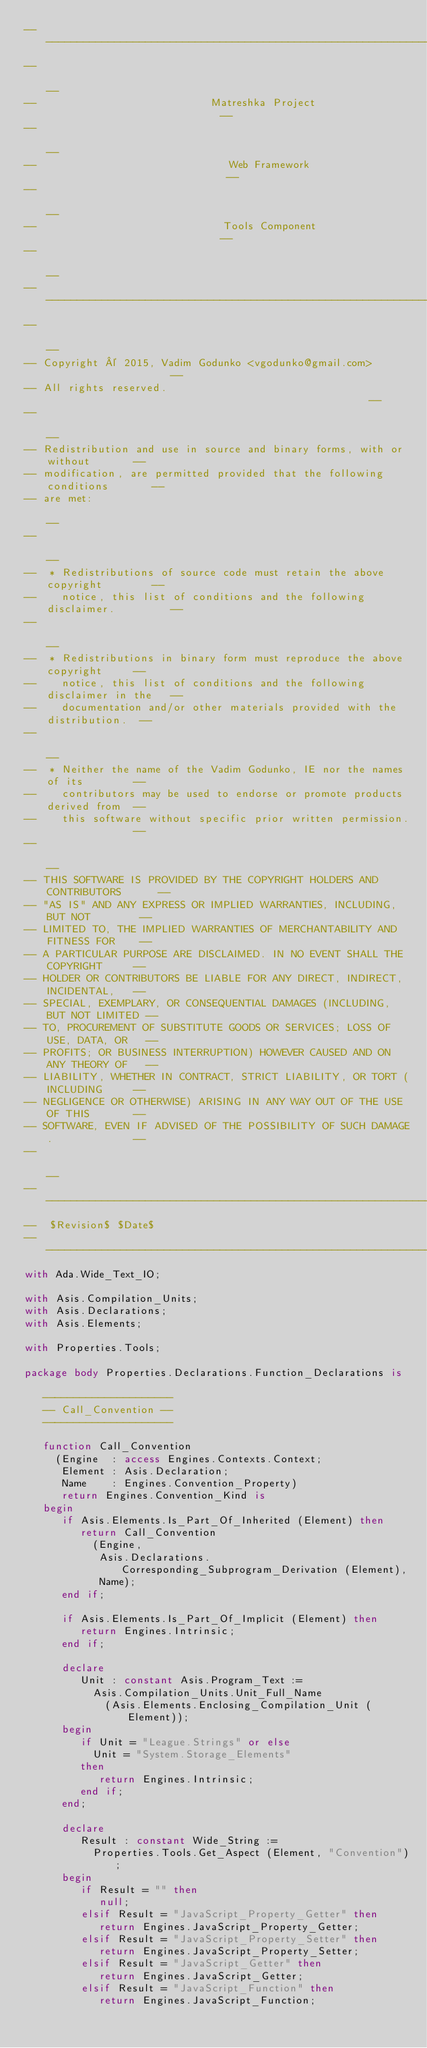<code> <loc_0><loc_0><loc_500><loc_500><_Ada_>------------------------------------------------------------------------------
--                                                                          --
--                            Matreshka Project                             --
--                                                                          --
--                               Web Framework                              --
--                                                                          --
--                              Tools Component                             --
--                                                                          --
------------------------------------------------------------------------------
--                                                                          --
-- Copyright © 2015, Vadim Godunko <vgodunko@gmail.com>                     --
-- All rights reserved.                                                     --
--                                                                          --
-- Redistribution and use in source and binary forms, with or without       --
-- modification, are permitted provided that the following conditions       --
-- are met:                                                                 --
--                                                                          --
--  * Redistributions of source code must retain the above copyright        --
--    notice, this list of conditions and the following disclaimer.         --
--                                                                          --
--  * Redistributions in binary form must reproduce the above copyright     --
--    notice, this list of conditions and the following disclaimer in the   --
--    documentation and/or other materials provided with the distribution.  --
--                                                                          --
--  * Neither the name of the Vadim Godunko, IE nor the names of its        --
--    contributors may be used to endorse or promote products derived from  --
--    this software without specific prior written permission.              --
--                                                                          --
-- THIS SOFTWARE IS PROVIDED BY THE COPYRIGHT HOLDERS AND CONTRIBUTORS      --
-- "AS IS" AND ANY EXPRESS OR IMPLIED WARRANTIES, INCLUDING, BUT NOT        --
-- LIMITED TO, THE IMPLIED WARRANTIES OF MERCHANTABILITY AND FITNESS FOR    --
-- A PARTICULAR PURPOSE ARE DISCLAIMED. IN NO EVENT SHALL THE COPYRIGHT     --
-- HOLDER OR CONTRIBUTORS BE LIABLE FOR ANY DIRECT, INDIRECT, INCIDENTAL,   --
-- SPECIAL, EXEMPLARY, OR CONSEQUENTIAL DAMAGES (INCLUDING, BUT NOT LIMITED --
-- TO, PROCUREMENT OF SUBSTITUTE GOODS OR SERVICES; LOSS OF USE, DATA, OR   --
-- PROFITS; OR BUSINESS INTERRUPTION) HOWEVER CAUSED AND ON ANY THEORY OF   --
-- LIABILITY, WHETHER IN CONTRACT, STRICT LIABILITY, OR TORT (INCLUDING     --
-- NEGLIGENCE OR OTHERWISE) ARISING IN ANY WAY OUT OF THE USE OF THIS       --
-- SOFTWARE, EVEN IF ADVISED OF THE POSSIBILITY OF SUCH DAMAGE.             --
--                                                                          --
------------------------------------------------------------------------------
--  $Revision$ $Date$
------------------------------------------------------------------------------
with Ada.Wide_Text_IO;

with Asis.Compilation_Units;
with Asis.Declarations;
with Asis.Elements;

with Properties.Tools;

package body Properties.Declarations.Function_Declarations is

   ---------------------
   -- Call_Convention --
   ---------------------

   function Call_Convention
     (Engine  : access Engines.Contexts.Context;
      Element : Asis.Declaration;
      Name    : Engines.Convention_Property)
      return Engines.Convention_Kind is
   begin
      if Asis.Elements.Is_Part_Of_Inherited (Element) then
         return Call_Convention
           (Engine,
            Asis.Declarations.Corresponding_Subprogram_Derivation (Element),
            Name);
      end if;

      if Asis.Elements.Is_Part_Of_Implicit (Element) then
         return Engines.Intrinsic;
      end if;

      declare
         Unit : constant Asis.Program_Text :=
           Asis.Compilation_Units.Unit_Full_Name
             (Asis.Elements.Enclosing_Compilation_Unit (Element));
      begin
         if Unit = "League.Strings" or else
           Unit = "System.Storage_Elements"
         then
            return Engines.Intrinsic;
         end if;
      end;

      declare
         Result : constant Wide_String :=
           Properties.Tools.Get_Aspect (Element, "Convention");
      begin
         if Result = "" then
            null;
         elsif Result = "JavaScript_Property_Getter" then
            return Engines.JavaScript_Property_Getter;
         elsif Result = "JavaScript_Property_Setter" then
            return Engines.JavaScript_Property_Setter;
         elsif Result = "JavaScript_Getter" then
            return Engines.JavaScript_Getter;
         elsif Result = "JavaScript_Function" then
            return Engines.JavaScript_Function;</code> 